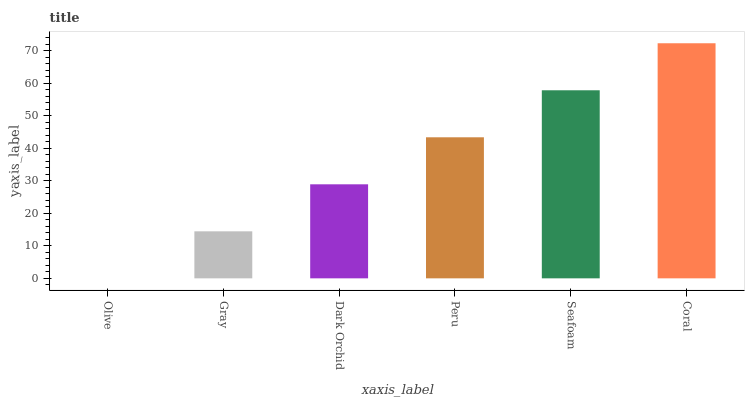Is Gray the minimum?
Answer yes or no. No. Is Gray the maximum?
Answer yes or no. No. Is Gray greater than Olive?
Answer yes or no. Yes. Is Olive less than Gray?
Answer yes or no. Yes. Is Olive greater than Gray?
Answer yes or no. No. Is Gray less than Olive?
Answer yes or no. No. Is Peru the high median?
Answer yes or no. Yes. Is Dark Orchid the low median?
Answer yes or no. Yes. Is Olive the high median?
Answer yes or no. No. Is Olive the low median?
Answer yes or no. No. 